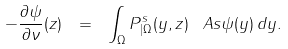Convert formula to latex. <formula><loc_0><loc_0><loc_500><loc_500>- \frac { \partial \psi } { \partial \nu } ( z ) \ = \ \int _ { \Omega } P _ { | \Omega } ^ { s } ( y , z ) \, \ A s \psi ( y ) \, d y .</formula> 